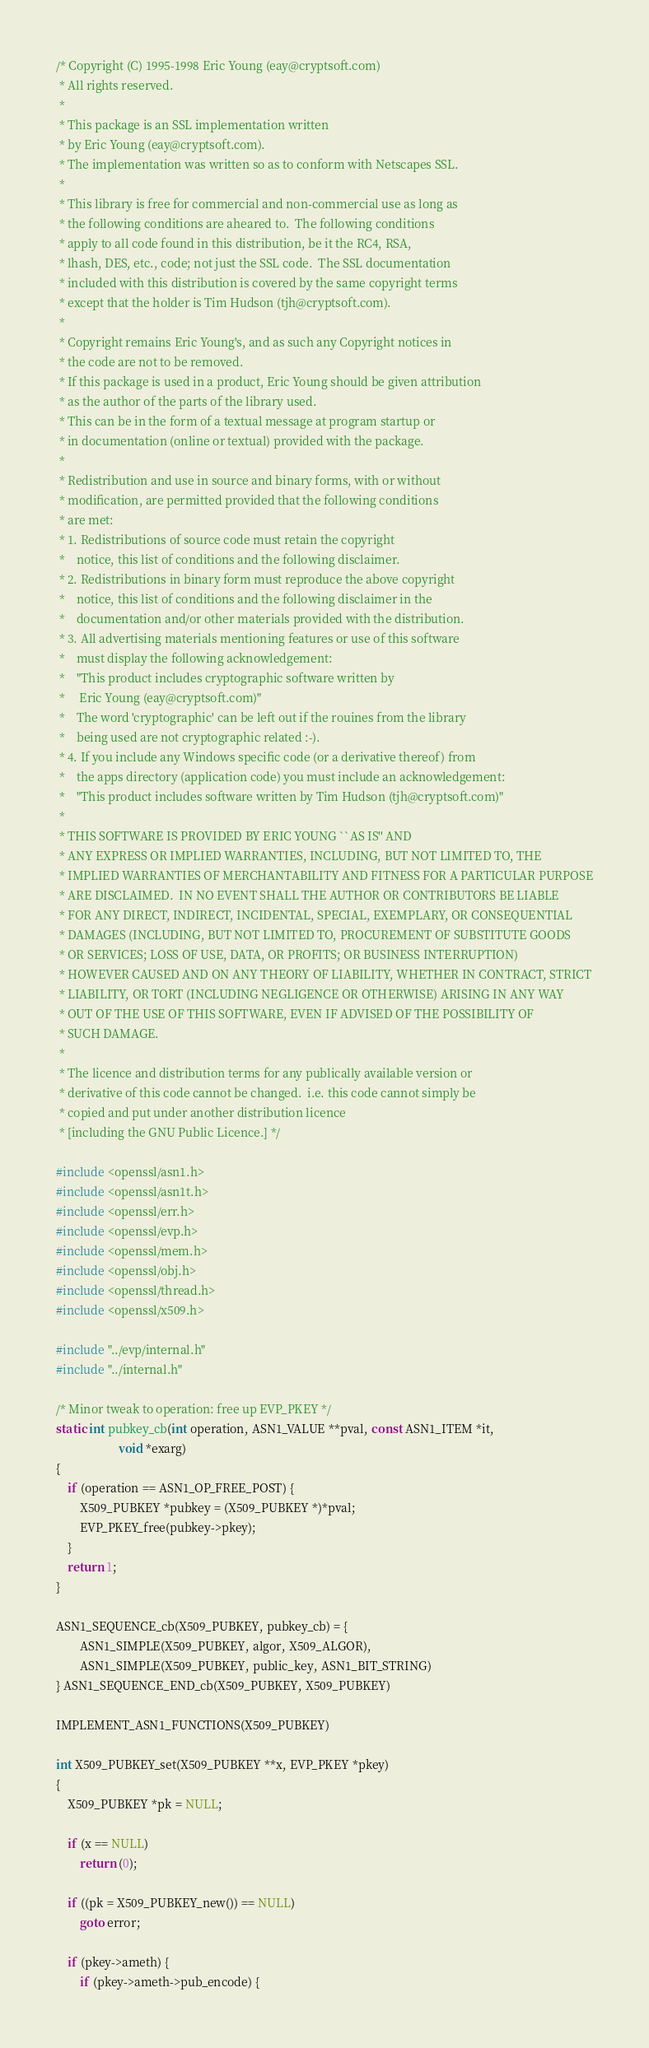Convert code to text. <code><loc_0><loc_0><loc_500><loc_500><_C_>/* Copyright (C) 1995-1998 Eric Young (eay@cryptsoft.com)
 * All rights reserved.
 *
 * This package is an SSL implementation written
 * by Eric Young (eay@cryptsoft.com).
 * The implementation was written so as to conform with Netscapes SSL.
 *
 * This library is free for commercial and non-commercial use as long as
 * the following conditions are aheared to.  The following conditions
 * apply to all code found in this distribution, be it the RC4, RSA,
 * lhash, DES, etc., code; not just the SSL code.  The SSL documentation
 * included with this distribution is covered by the same copyright terms
 * except that the holder is Tim Hudson (tjh@cryptsoft.com).
 *
 * Copyright remains Eric Young's, and as such any Copyright notices in
 * the code are not to be removed.
 * If this package is used in a product, Eric Young should be given attribution
 * as the author of the parts of the library used.
 * This can be in the form of a textual message at program startup or
 * in documentation (online or textual) provided with the package.
 *
 * Redistribution and use in source and binary forms, with or without
 * modification, are permitted provided that the following conditions
 * are met:
 * 1. Redistributions of source code must retain the copyright
 *    notice, this list of conditions and the following disclaimer.
 * 2. Redistributions in binary form must reproduce the above copyright
 *    notice, this list of conditions and the following disclaimer in the
 *    documentation and/or other materials provided with the distribution.
 * 3. All advertising materials mentioning features or use of this software
 *    must display the following acknowledgement:
 *    "This product includes cryptographic software written by
 *     Eric Young (eay@cryptsoft.com)"
 *    The word 'cryptographic' can be left out if the rouines from the library
 *    being used are not cryptographic related :-).
 * 4. If you include any Windows specific code (or a derivative thereof) from
 *    the apps directory (application code) you must include an acknowledgement:
 *    "This product includes software written by Tim Hudson (tjh@cryptsoft.com)"
 *
 * THIS SOFTWARE IS PROVIDED BY ERIC YOUNG ``AS IS'' AND
 * ANY EXPRESS OR IMPLIED WARRANTIES, INCLUDING, BUT NOT LIMITED TO, THE
 * IMPLIED WARRANTIES OF MERCHANTABILITY AND FITNESS FOR A PARTICULAR PURPOSE
 * ARE DISCLAIMED.  IN NO EVENT SHALL THE AUTHOR OR CONTRIBUTORS BE LIABLE
 * FOR ANY DIRECT, INDIRECT, INCIDENTAL, SPECIAL, EXEMPLARY, OR CONSEQUENTIAL
 * DAMAGES (INCLUDING, BUT NOT LIMITED TO, PROCUREMENT OF SUBSTITUTE GOODS
 * OR SERVICES; LOSS OF USE, DATA, OR PROFITS; OR BUSINESS INTERRUPTION)
 * HOWEVER CAUSED AND ON ANY THEORY OF LIABILITY, WHETHER IN CONTRACT, STRICT
 * LIABILITY, OR TORT (INCLUDING NEGLIGENCE OR OTHERWISE) ARISING IN ANY WAY
 * OUT OF THE USE OF THIS SOFTWARE, EVEN IF ADVISED OF THE POSSIBILITY OF
 * SUCH DAMAGE.
 *
 * The licence and distribution terms for any publically available version or
 * derivative of this code cannot be changed.  i.e. this code cannot simply be
 * copied and put under another distribution licence
 * [including the GNU Public Licence.] */

#include <openssl/asn1.h>
#include <openssl/asn1t.h>
#include <openssl/err.h>
#include <openssl/evp.h>
#include <openssl/mem.h>
#include <openssl/obj.h>
#include <openssl/thread.h>
#include <openssl/x509.h>

#include "../evp/internal.h"
#include "../internal.h"

/* Minor tweak to operation: free up EVP_PKEY */
static int pubkey_cb(int operation, ASN1_VALUE **pval, const ASN1_ITEM *it,
                     void *exarg)
{
    if (operation == ASN1_OP_FREE_POST) {
        X509_PUBKEY *pubkey = (X509_PUBKEY *)*pval;
        EVP_PKEY_free(pubkey->pkey);
    }
    return 1;
}

ASN1_SEQUENCE_cb(X509_PUBKEY, pubkey_cb) = {
        ASN1_SIMPLE(X509_PUBKEY, algor, X509_ALGOR),
        ASN1_SIMPLE(X509_PUBKEY, public_key, ASN1_BIT_STRING)
} ASN1_SEQUENCE_END_cb(X509_PUBKEY, X509_PUBKEY)

IMPLEMENT_ASN1_FUNCTIONS(X509_PUBKEY)

int X509_PUBKEY_set(X509_PUBKEY **x, EVP_PKEY *pkey)
{
    X509_PUBKEY *pk = NULL;

    if (x == NULL)
        return (0);

    if ((pk = X509_PUBKEY_new()) == NULL)
        goto error;

    if (pkey->ameth) {
        if (pkey->ameth->pub_encode) {</code> 